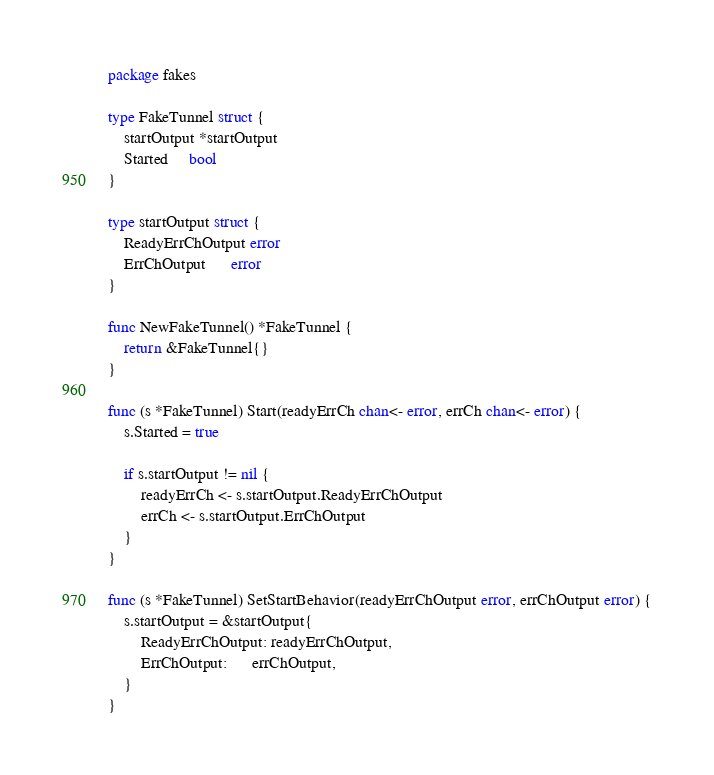Convert code to text. <code><loc_0><loc_0><loc_500><loc_500><_Go_>package fakes

type FakeTunnel struct {
	startOutput *startOutput
	Started     bool
}

type startOutput struct {
	ReadyErrChOutput error
	ErrChOutput      error
}

func NewFakeTunnel() *FakeTunnel {
	return &FakeTunnel{}
}

func (s *FakeTunnel) Start(readyErrCh chan<- error, errCh chan<- error) {
	s.Started = true

	if s.startOutput != nil {
		readyErrCh <- s.startOutput.ReadyErrChOutput
		errCh <- s.startOutput.ErrChOutput
	}
}

func (s *FakeTunnel) SetStartBehavior(readyErrChOutput error, errChOutput error) {
	s.startOutput = &startOutput{
		ReadyErrChOutput: readyErrChOutput,
		ErrChOutput:      errChOutput,
	}
}
</code> 